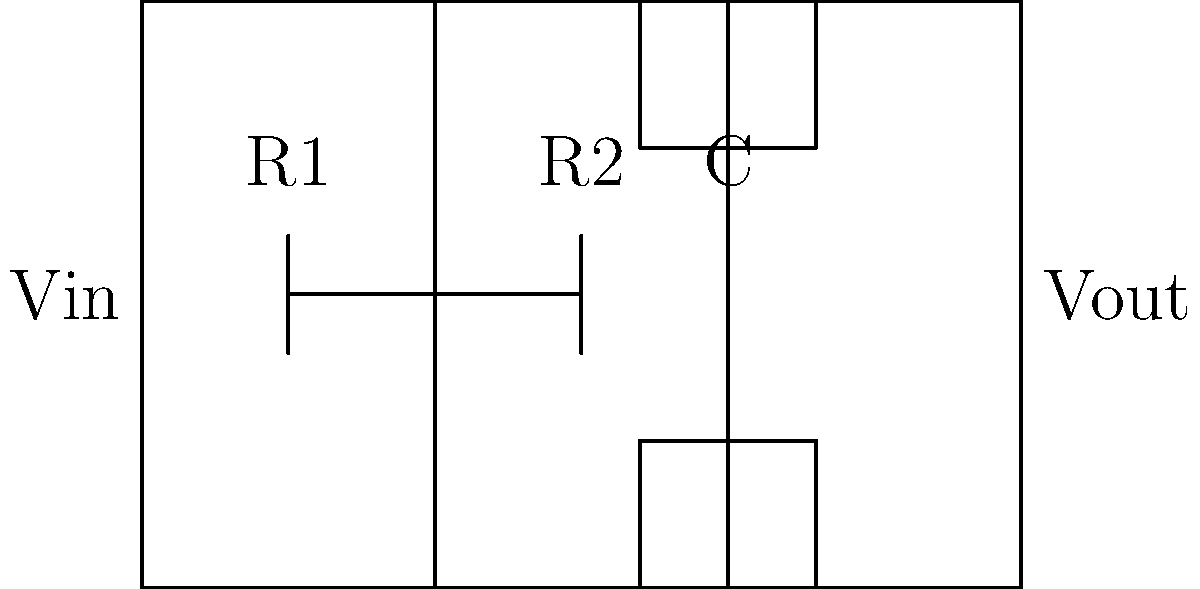In the given circuit diagram, if the input voltage $V_{in}$ is a sinusoidal signal with frequency $f$, how will the output voltage $V_{out}$ change as the frequency increases? Consider the effect of the capacitor C on the circuit's behavior. To understand how $V_{out}$ changes with increasing frequency, we need to analyze the circuit's behavior:

1. The circuit shown is a low-pass RC filter, consisting of two resistors (R1 and R2) and a capacitor (C).

2. At low frequencies:
   - The capacitor acts like an open circuit.
   - $V_{out}$ is approximately equal to $V_{in}$.
   - The circuit behaves like a voltage divider with R1 and R2.

3. As frequency increases:
   - The capacitor's impedance decreases: $X_C = \frac{1}{2\pi fC}$
   - More current flows through the capacitor.
   - The voltage across the capacitor (which is $V_{out}$) decreases.

4. At high frequencies:
   - The capacitor acts like a short circuit.
   - $V_{out}$ approaches zero.

5. The cutoff frequency $f_c$ of this filter is given by:
   $f_c = \frac{1}{2\pi (R1 + R2)C}$

6. As $f$ increases beyond $f_c$, $V_{out}$ decreases at a rate of approximately -20 dB/decade.

Therefore, as the frequency of $V_{in}$ increases, $V_{out}$ will decrease in amplitude, effectively attenuating high-frequency components of the input signal.
Answer: $V_{out}$ decreases in amplitude as frequency increases. 